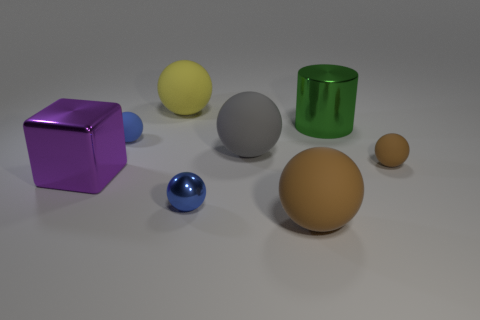What size is the brown ball that is behind the tiny blue sphere in front of the small brown object?
Your answer should be very brief. Small. Are there more small blue objects than tiny spheres?
Provide a short and direct response. No. Is the color of the ball that is in front of the tiny blue metal ball the same as the rubber thing that is right of the big brown rubber ball?
Your answer should be very brief. Yes. Is there a brown rubber object behind the brown matte ball in front of the tiny brown matte ball?
Give a very brief answer. Yes. Are there fewer matte spheres that are left of the yellow thing than large rubber balls that are behind the small blue shiny thing?
Your response must be concise. Yes. Is the small blue sphere behind the gray sphere made of the same material as the blue object in front of the small brown ball?
Your answer should be compact. No. How many small objects are gray spheres or gray shiny things?
Your answer should be compact. 0. What shape is the other small thing that is the same material as the purple object?
Make the answer very short. Sphere. Is the number of big shiny cubes right of the big brown thing less than the number of metal balls?
Offer a very short reply. Yes. Does the big purple thing have the same shape as the tiny blue metallic object?
Offer a terse response. No. 